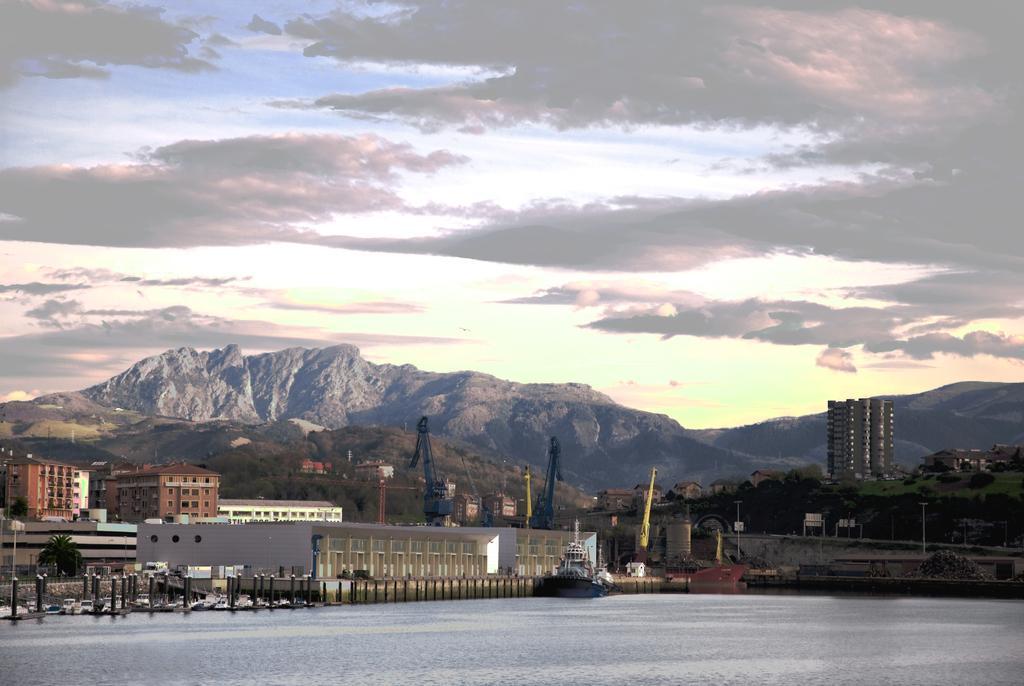Please provide a concise description of this image. In this image, I can see the buildings, trees, tower cranes, hills and poles. At the bottom of the image, there is a boat on the water. In the background, I can see the sky. 